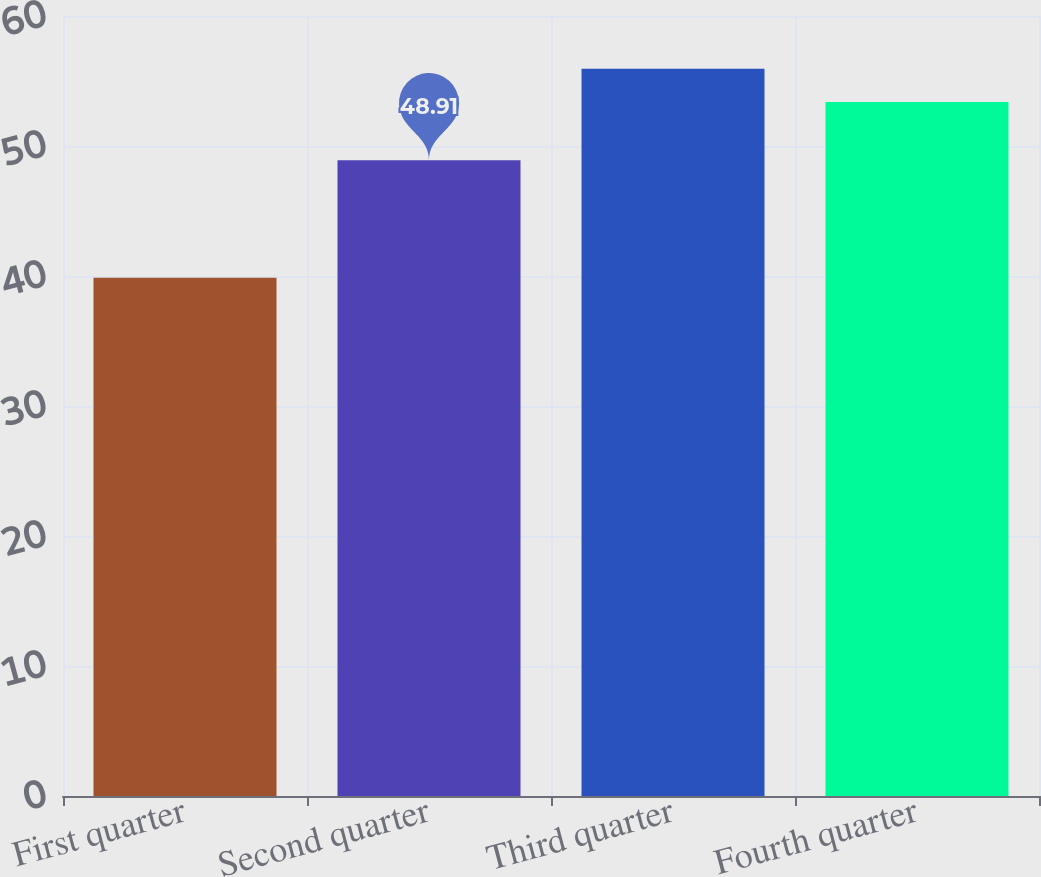<chart> <loc_0><loc_0><loc_500><loc_500><bar_chart><fcel>First quarter<fcel>Second quarter<fcel>Third quarter<fcel>Fourth quarter<nl><fcel>39.87<fcel>48.91<fcel>55.94<fcel>53.38<nl></chart> 